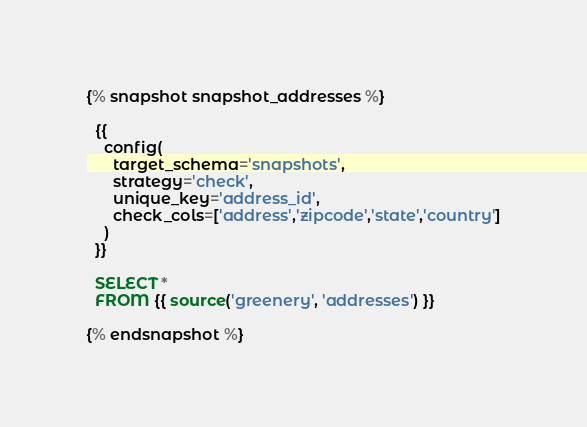Convert code to text. <code><loc_0><loc_0><loc_500><loc_500><_SQL_>{% snapshot snapshot_addresses %}

  {{
    config(
      target_schema='snapshots',
      strategy='check',
      unique_key='address_id',
      check_cols=['address','zipcode','state','country']
    )
  }}

  SELECT * 
  FROM {{ source('greenery', 'addresses') }}

{% endsnapshot %}</code> 